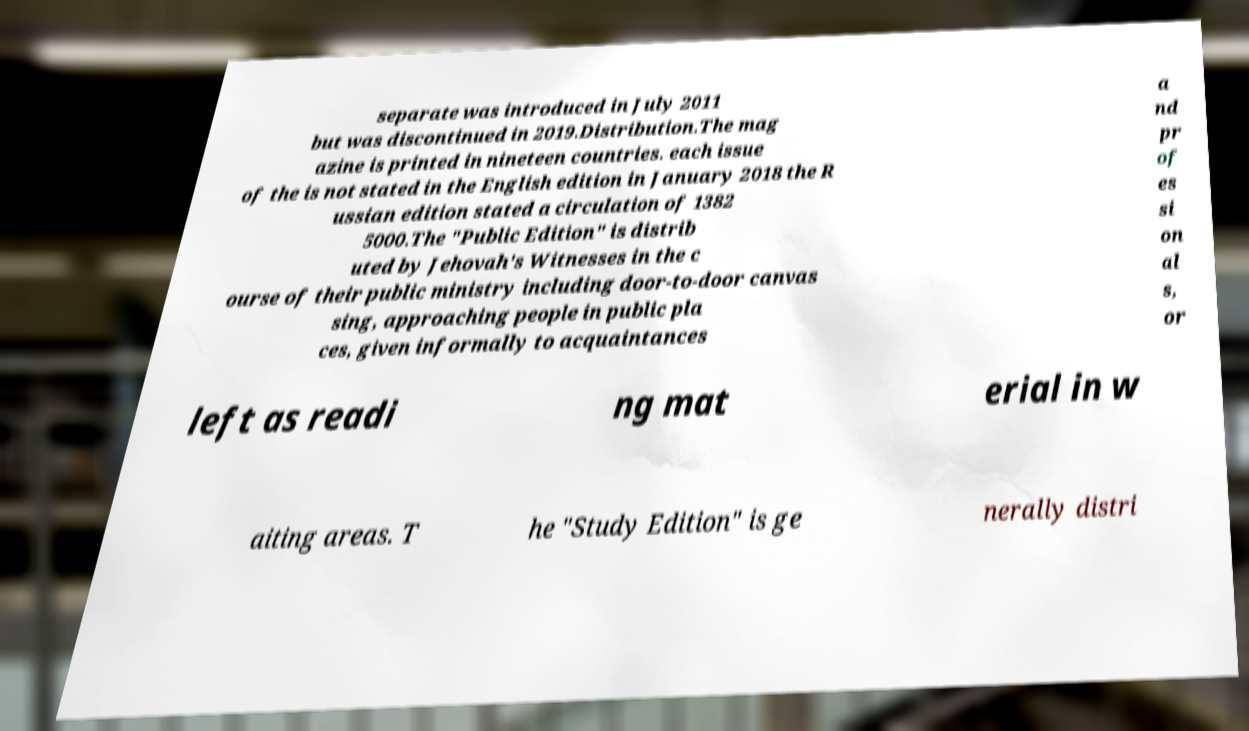I need the written content from this picture converted into text. Can you do that? separate was introduced in July 2011 but was discontinued in 2019.Distribution.The mag azine is printed in nineteen countries. each issue of the is not stated in the English edition in January 2018 the R ussian edition stated a circulation of 1382 5000.The "Public Edition" is distrib uted by Jehovah's Witnesses in the c ourse of their public ministry including door-to-door canvas sing, approaching people in public pla ces, given informally to acquaintances a nd pr of es si on al s, or left as readi ng mat erial in w aiting areas. T he "Study Edition" is ge nerally distri 